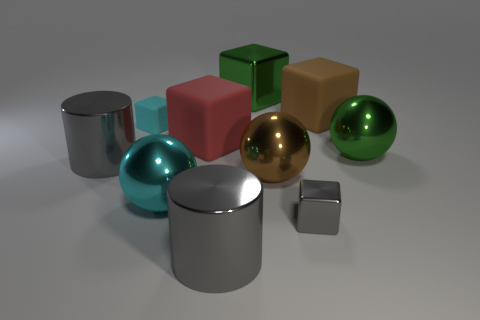Are the small gray cube and the tiny block behind the tiny gray block made of the same material?
Your response must be concise. No. The brown rubber thing that is right of the small gray metal thing has what shape?
Your answer should be very brief. Cube. How many other things are made of the same material as the cyan block?
Provide a succinct answer. 2. The red matte cube is what size?
Ensure brevity in your answer.  Large. How many other objects are the same color as the small metal object?
Provide a short and direct response. 2. What is the color of the block that is both on the right side of the big red cube and in front of the small cyan block?
Offer a terse response. Gray. What number of big metallic cylinders are there?
Make the answer very short. 2. Is the material of the big red cube the same as the small cyan block?
Provide a short and direct response. Yes. There is a brown object behind the large matte cube left of the gray metallic object that is in front of the tiny gray thing; what shape is it?
Your response must be concise. Cube. Is the material of the green object in front of the brown matte object the same as the red block on the right side of the small rubber cube?
Keep it short and to the point. No. 